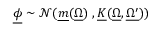<formula> <loc_0><loc_0><loc_500><loc_500>\underline { \phi } \sim \mathcal { N } ( \underline { m } ( \underline { \Omega } ) \, , \underline { K } ( \underline { \Omega } , \underline { { \Omega ^ { \prime } } } ) )</formula> 